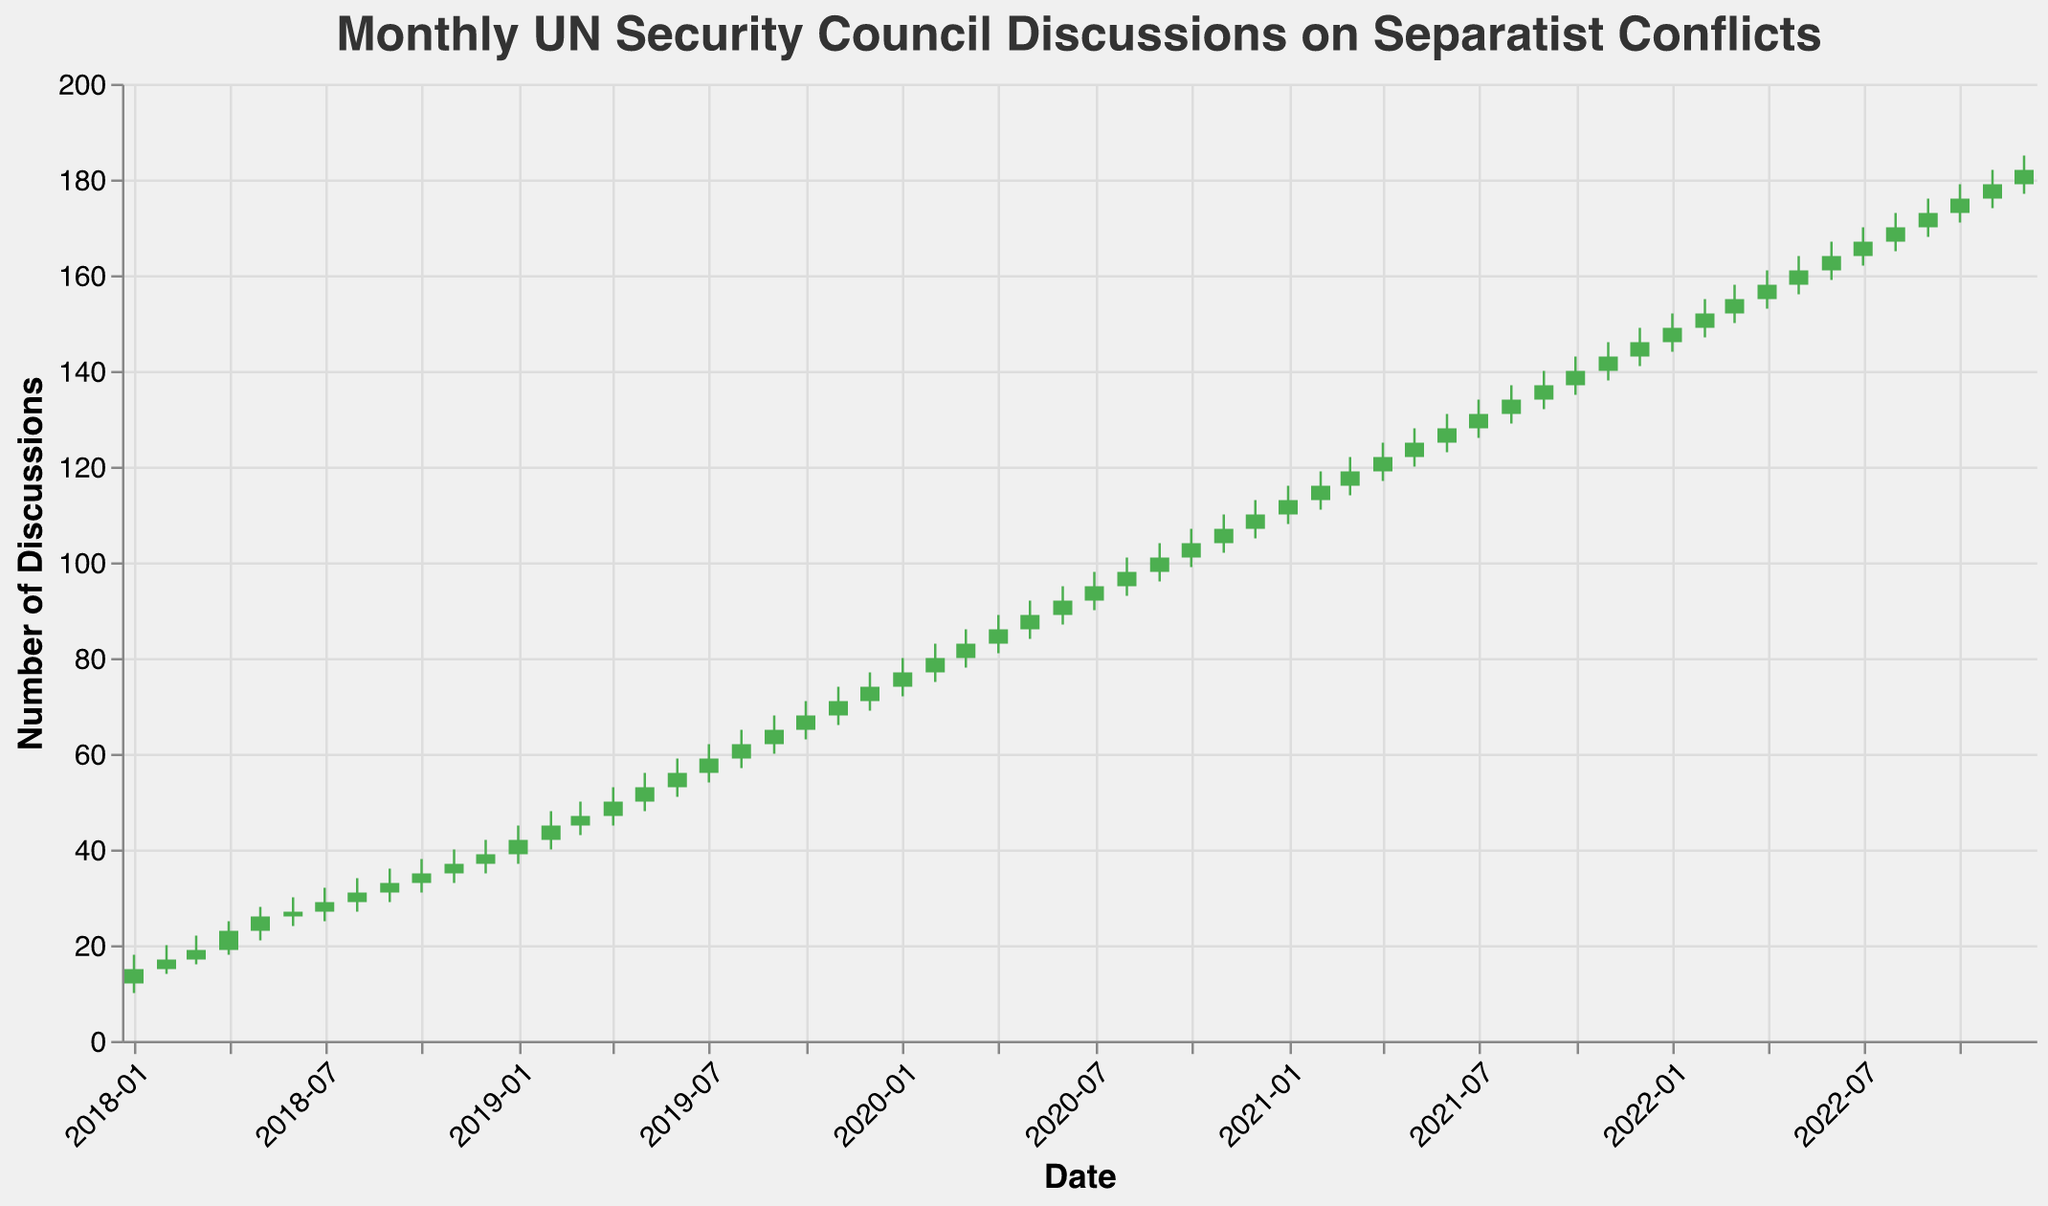What is the highest number of discussions in a single month? To determine the highest number of discussions, look for the highest value in the High column in the data. The peak value is 185 in December 2022.
Answer: 185 How many months showed an increase in the number of discussions compared to the previous month? By observing the Open and Close values, we can see an increase when the Close value is higher than the Open value. Count each instance from the data.
Answer: 59 In which month did the discussions show the highest increase compared to the previous month's closing value? Check for the month-to-month differences between the Closing values. The highest increase occurs between December 2019 (Close = 74) and January 2020 (Close = 77), which shows an increase of 3 discussions.
Answer: January 2020 What is the trend in UN Security Council discussions on separatist conflicts over the five-year period? By looking at how the closing values have changed from January 2018 to December 2022, we see a consistent upward trend in the number of discussions.
Answer: Upward trend Which month had the largest difference between the highest and lowest number of discussions? Calculate the difference between the High and Low values for each month and identify the maximum. The largest difference is in January 2019, which is 8 (High = 45, Low = 37).
Answer: January 2019 How many months have the same opening and closing values? Compare the Open and Close values for each month, and count the number of instances where they are equal.
Answer: 0 Which month experienced the most significant drop in discussions? Identify cases where the Close value is less than the Open value and find the month with the biggest difference. The largest drop is between December 2021 (Open = 143, Close = 146) and January 2022 (Open = 146, Close = 149), but no significant drop is seen overall.
Answer: No significant drop Which period saw the most consistent increase in discussion counts? Look for continuous months where the Close value consistently increases. From May 2019 to December 2019, each month shows a consistent rise in the Close values.
Answer: May 2019 to December 2019 